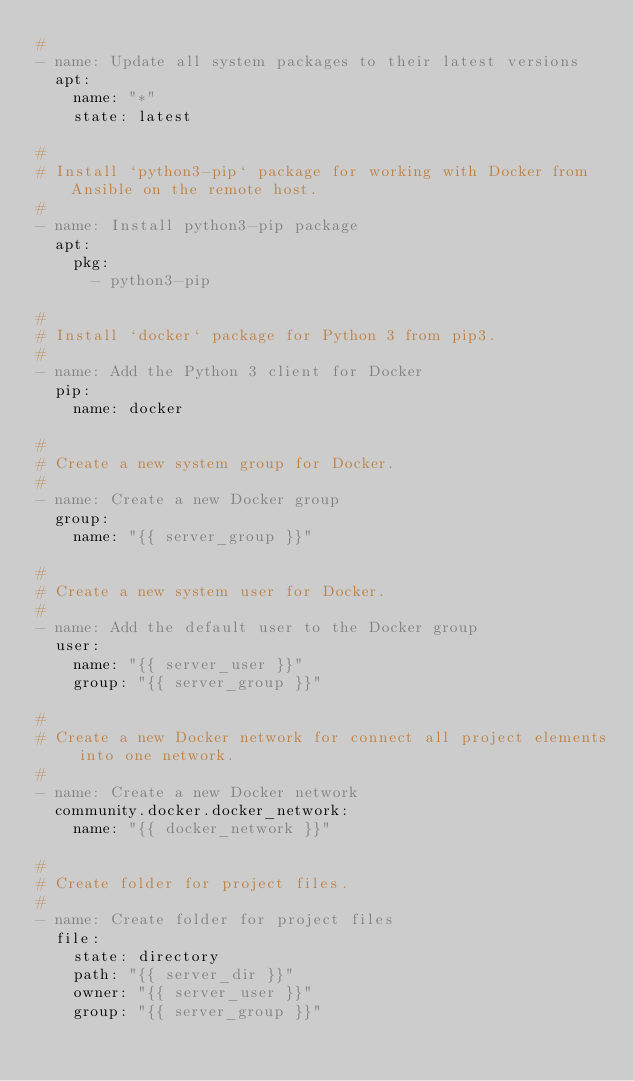Convert code to text. <code><loc_0><loc_0><loc_500><loc_500><_YAML_>#
- name: Update all system packages to their latest versions
  apt:
    name: "*"
    state: latest

#
# Install `python3-pip` package for working with Docker from Ansible on the remote host.
#
- name: Install python3-pip package
  apt:
    pkg:
      - python3-pip

#
# Install `docker` package for Python 3 from pip3.
#
- name: Add the Python 3 client for Docker
  pip:
    name: docker

#
# Create a new system group for Docker.
#
- name: Create a new Docker group
  group:
    name: "{{ server_group }}"

#
# Create a new system user for Docker.
#
- name: Add the default user to the Docker group
  user:
    name: "{{ server_user }}"
    group: "{{ server_group }}"

#
# Create a new Docker network for connect all project elements into one network.
#
- name: Create a new Docker network
  community.docker.docker_network:
    name: "{{ docker_network }}"

#
# Create folder for project files.
#
- name: Create folder for project files
  file:
    state: directory
    path: "{{ server_dir }}"
    owner: "{{ server_user }}"
    group: "{{ server_group }}"
</code> 